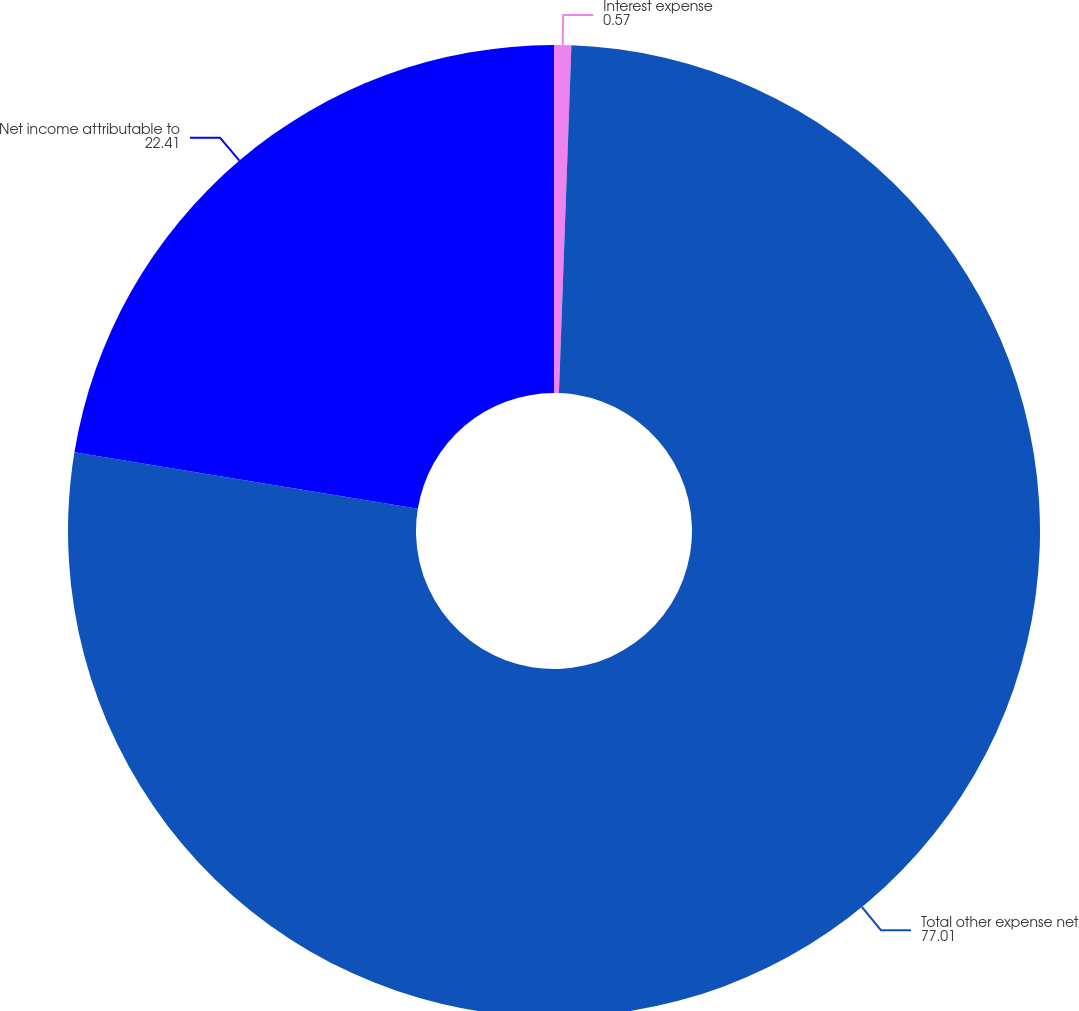Convert chart. <chart><loc_0><loc_0><loc_500><loc_500><pie_chart><fcel>Interest expense<fcel>Total other expense net<fcel>Net income attributable to<nl><fcel>0.57%<fcel>77.01%<fcel>22.41%<nl></chart> 